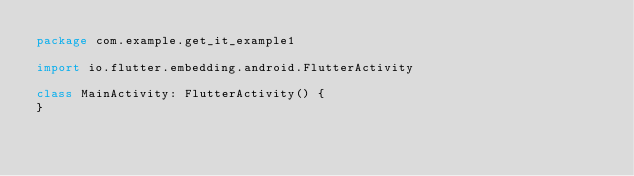Convert code to text. <code><loc_0><loc_0><loc_500><loc_500><_Kotlin_>package com.example.get_it_example1

import io.flutter.embedding.android.FlutterActivity

class MainActivity: FlutterActivity() {
}
</code> 